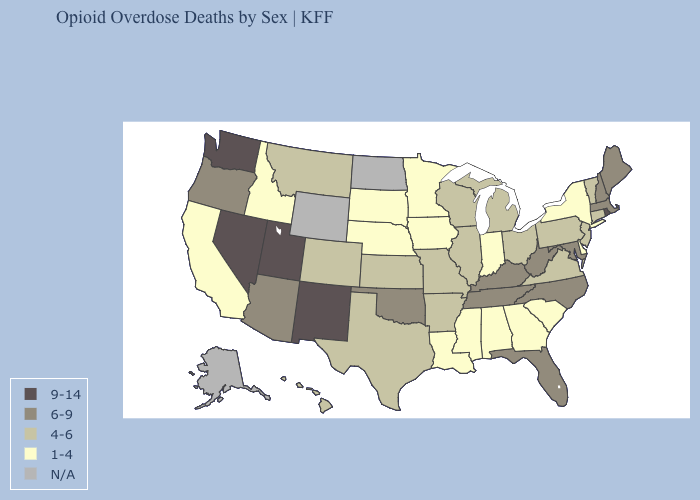What is the highest value in states that border Minnesota?
Concise answer only. 4-6. Does Utah have the highest value in the West?
Short answer required. Yes. How many symbols are there in the legend?
Give a very brief answer. 5. Which states have the lowest value in the West?
Give a very brief answer. California, Idaho. Name the states that have a value in the range 4-6?
Be succinct. Arkansas, Colorado, Connecticut, Hawaii, Illinois, Kansas, Michigan, Missouri, Montana, New Jersey, Ohio, Pennsylvania, Texas, Vermont, Virginia, Wisconsin. What is the value of Rhode Island?
Give a very brief answer. 9-14. Name the states that have a value in the range 4-6?
Keep it brief. Arkansas, Colorado, Connecticut, Hawaii, Illinois, Kansas, Michigan, Missouri, Montana, New Jersey, Ohio, Pennsylvania, Texas, Vermont, Virginia, Wisconsin. Which states have the lowest value in the West?
Be succinct. California, Idaho. What is the highest value in the USA?
Keep it brief. 9-14. Which states have the lowest value in the USA?
Quick response, please. Alabama, California, Delaware, Georgia, Idaho, Indiana, Iowa, Louisiana, Minnesota, Mississippi, Nebraska, New York, South Carolina, South Dakota. Among the states that border New York , which have the lowest value?
Concise answer only. Connecticut, New Jersey, Pennsylvania, Vermont. Name the states that have a value in the range 1-4?
Answer briefly. Alabama, California, Delaware, Georgia, Idaho, Indiana, Iowa, Louisiana, Minnesota, Mississippi, Nebraska, New York, South Carolina, South Dakota. Among the states that border Illinois , does Iowa have the highest value?
Give a very brief answer. No. Which states have the highest value in the USA?
Write a very short answer. Nevada, New Mexico, Rhode Island, Utah, Washington. What is the value of Vermont?
Be succinct. 4-6. 